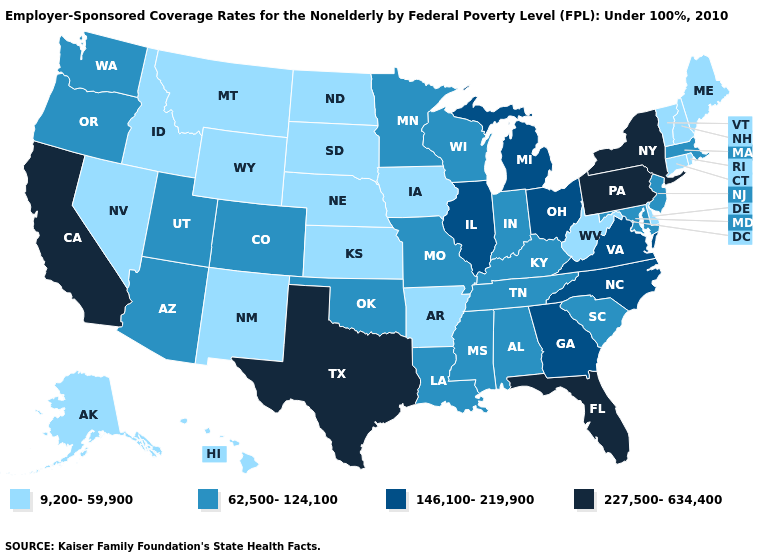Name the states that have a value in the range 9,200-59,900?
Quick response, please. Alaska, Arkansas, Connecticut, Delaware, Hawaii, Idaho, Iowa, Kansas, Maine, Montana, Nebraska, Nevada, New Hampshire, New Mexico, North Dakota, Rhode Island, South Dakota, Vermont, West Virginia, Wyoming. What is the value of Utah?
Write a very short answer. 62,500-124,100. What is the value of Mississippi?
Quick response, please. 62,500-124,100. Name the states that have a value in the range 227,500-634,400?
Answer briefly. California, Florida, New York, Pennsylvania, Texas. How many symbols are there in the legend?
Be succinct. 4. What is the value of Ohio?
Write a very short answer. 146,100-219,900. How many symbols are there in the legend?
Keep it brief. 4. What is the lowest value in the West?
Be succinct. 9,200-59,900. What is the value of Tennessee?
Concise answer only. 62,500-124,100. What is the lowest value in states that border Oklahoma?
Write a very short answer. 9,200-59,900. What is the lowest value in the USA?
Give a very brief answer. 9,200-59,900. What is the lowest value in states that border Montana?
Give a very brief answer. 9,200-59,900. Among the states that border Utah , does Idaho have the highest value?
Concise answer only. No. Which states have the highest value in the USA?
Short answer required. California, Florida, New York, Pennsylvania, Texas. Does Texas have a lower value than Illinois?
Quick response, please. No. 